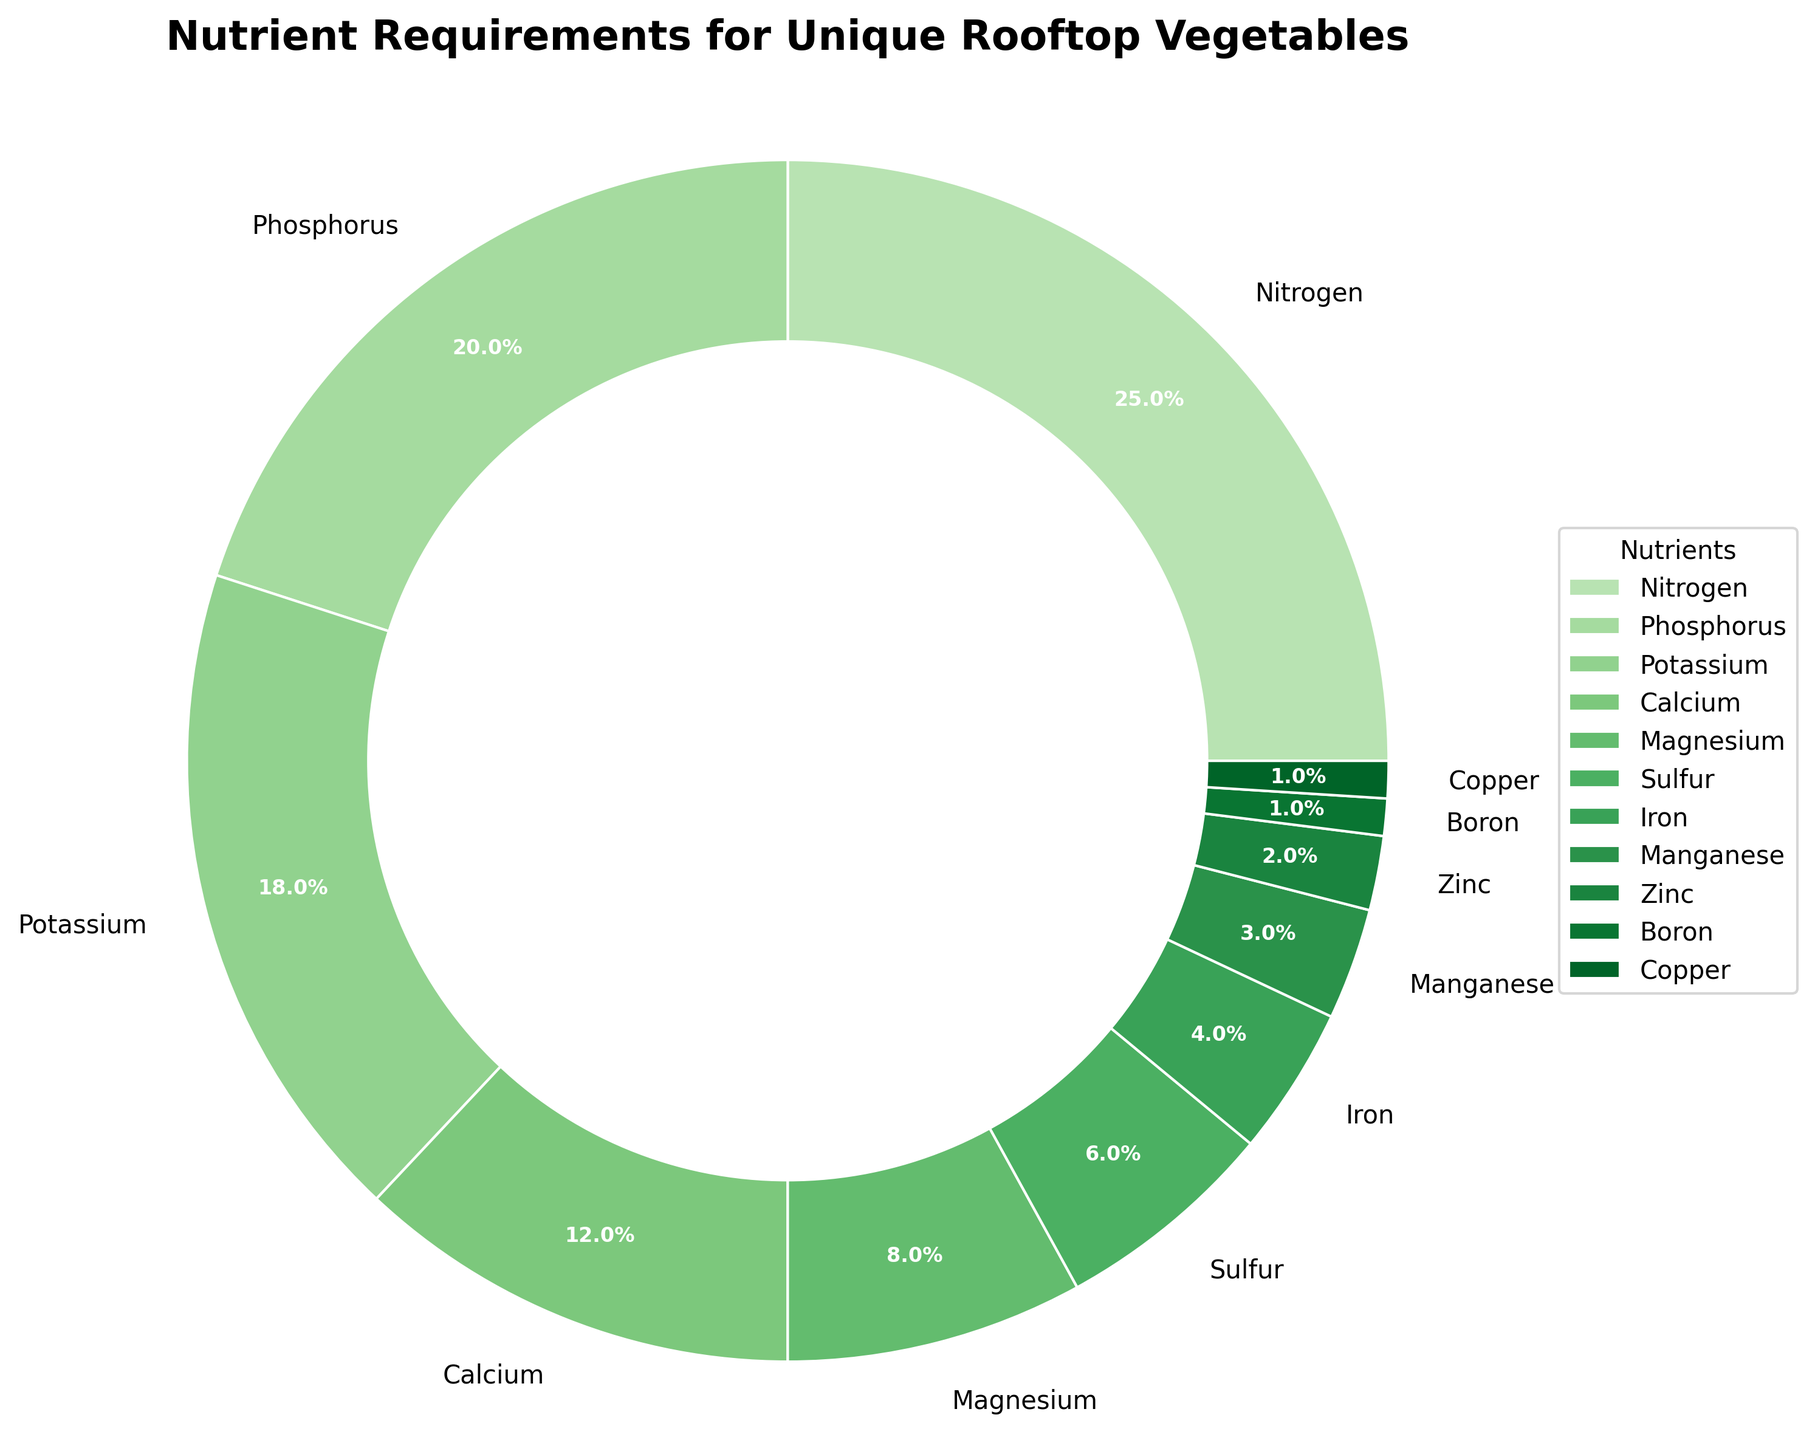What nutrient has the highest percentage requirement? The pie chart shows different segments for each nutrient with percentages. The largest segment represents the nutrient with the highest requirement. This segment is labeled "Nitrogen" at 25%.
Answer: Nitrogen Which nutrients make up more than 15% of the requirement? By examining the pie chart, we can identify nutrients whose segments are larger than 15%. The segments for Nitrogen, Phosphorus, and Potassium are labeled with percentages above 15%.
Answer: Nitrogen, Phosphorus, Potassium What's the combined percentage of Calcium, Magnesium, and Sulfur? To find the combined percentage, add the individual percentages of Calcium (12%), Magnesium (8%), and Sulfur (6%) together: 12% + 8% + 6% = 26%.
Answer: 26% Which nutrient has the smallest percentage requirement? The pie chart segment with the smallest percentage will be the answer. Based on percentages, Boron and Copper both have the smallest requirement at 1%.
Answer: Boron, Copper Is the percentage requirement for Iron greater than that for Zinc? Compare the segments for Iron and Zinc. Iron is labeled with a 4% requirement, while Zinc has a 2% requirement. Since 4% is greater than 2%, Iron's requirement is greater.
Answer: Yes What is the difference in percentage requirements between Nitrogen and Calcium? The requirement for Nitrogen is 25% and for Calcium is 12%. The difference is calculated as 25% - 12% = 13%.
Answer: 13% How many nutrients have a requirement less than 5%? Identify and count the nutrients with segments labeled less than 5%. These nutrients are Iron (4%), Manganese (3%), Zinc (2%), Boron (1%), Copper (1%). There are 5 such nutrients.
Answer: 5 What percentage of nutrients is required for Phosphorus, Potassium, and Manganese combined? Adding the percentages for Phosphorus (20%), Potassium (18%), and Manganese (3%) gives us 20% + 18% + 3% = 41%.
Answer: 41% Which nutrient's requirement is exactly half of Nitrogen's requirement? Nitrogen’s requirement is 25%. Half of this value is 12.5%. Comparing this to the nutrient requirement percentages, it does not match exactly with any nutrient. Thus, none of the nutrients meet this condition.
Answer: None What is the average percentage requirement for the nutrients? To calculate the average, sum up all the nutrient requirement percentages and divide by the number of nutrients. Total percentage is 100% and there are 11 nutrients, so the average is 100% / 11 ≈ 9.09%.
Answer: 9.09% 